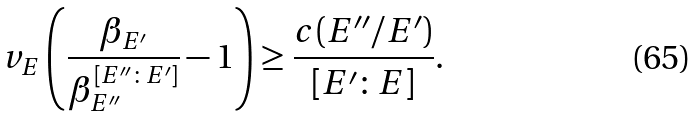<formula> <loc_0><loc_0><loc_500><loc_500>v _ { E } \left ( \frac { \beta _ { E ^ { \prime } } } { \beta _ { E ^ { \prime \prime } } ^ { [ E ^ { \prime \prime } \colon E ^ { \prime } ] } } - 1 \right ) \geq \frac { c ( E ^ { \prime \prime } / E ^ { \prime } ) } { [ E ^ { \prime } \colon E ] } .</formula> 